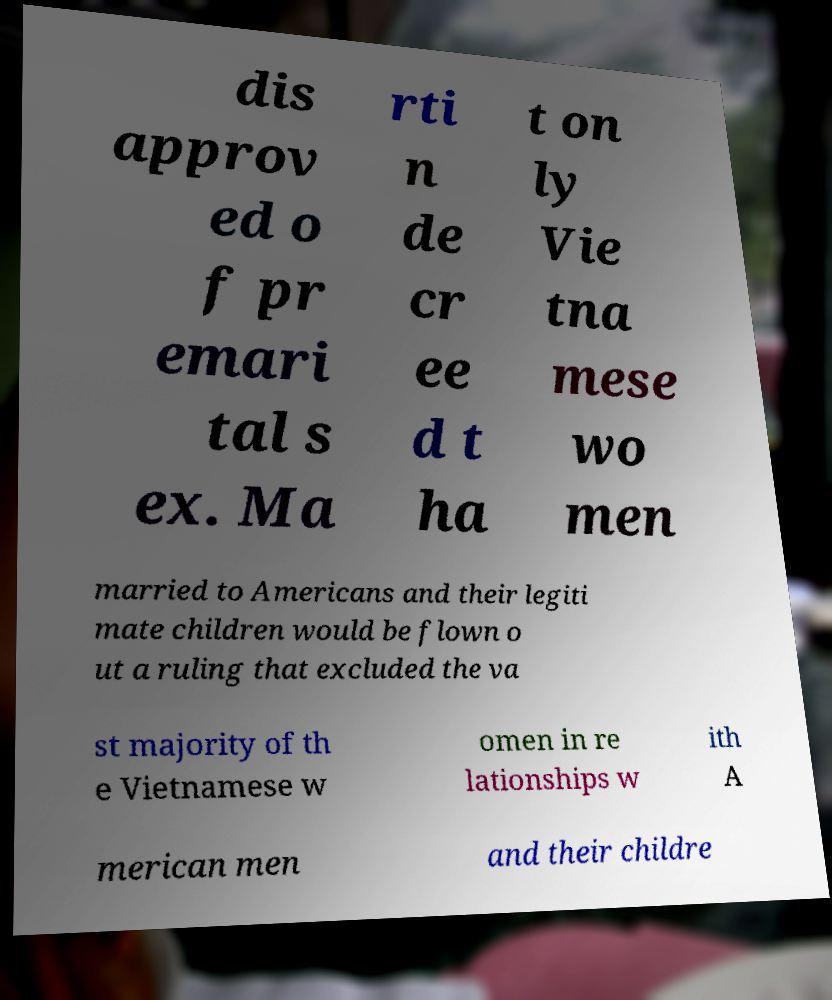There's text embedded in this image that I need extracted. Can you transcribe it verbatim? dis approv ed o f pr emari tal s ex. Ma rti n de cr ee d t ha t on ly Vie tna mese wo men married to Americans and their legiti mate children would be flown o ut a ruling that excluded the va st majority of th e Vietnamese w omen in re lationships w ith A merican men and their childre 